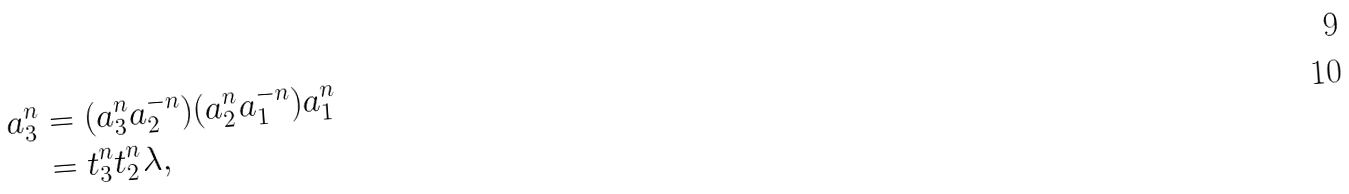Convert formula to latex. <formula><loc_0><loc_0><loc_500><loc_500>a _ { 3 } ^ { n } & = ( a _ { 3 } ^ { n } a _ { 2 } ^ { - n } ) ( a _ { 2 } ^ { n } a _ { 1 } ^ { - n } ) a _ { 1 } ^ { n } \\ & = t _ { 3 } ^ { n } t _ { 2 } ^ { n } \lambda ,</formula> 